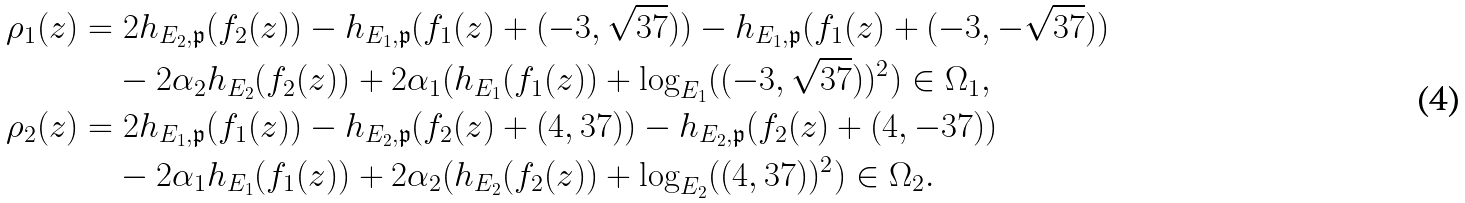Convert formula to latex. <formula><loc_0><loc_0><loc_500><loc_500>\rho _ { 1 } ( z ) & = 2 h _ { E _ { 2 } , \mathfrak { p } } ( f _ { 2 } ( z ) ) - h _ { E _ { 1 } , \mathfrak { p } } ( f _ { 1 } ( z ) + ( - 3 , \sqrt { 3 7 } ) ) - h _ { E _ { 1 } , \mathfrak { p } } ( f _ { 1 } ( z ) + ( - 3 , - \sqrt { 3 7 } ) ) \\ & \quad - 2 \alpha _ { 2 } h _ { E _ { 2 } } ( f _ { 2 } ( z ) ) + 2 \alpha _ { 1 } ( h _ { E _ { 1 } } ( f _ { 1 } ( z ) ) + \log _ { E _ { 1 } } ( ( - 3 , \sqrt { 3 7 } ) ) ^ { 2 } ) \in \Omega _ { 1 } , \\ \rho _ { 2 } ( z ) & = 2 h _ { E _ { 1 } , \mathfrak { p } } ( f _ { 1 } ( z ) ) - h _ { E _ { 2 } , \mathfrak { p } } ( f _ { 2 } ( z ) + ( 4 , 3 7 ) ) - h _ { E _ { 2 } , \mathfrak { p } } ( f _ { 2 } ( z ) + ( 4 , - 3 7 ) ) \\ & \quad - 2 \alpha _ { 1 } h _ { E _ { 1 } } ( f _ { 1 } ( z ) ) + 2 \alpha _ { 2 } ( h _ { E _ { 2 } } ( f _ { 2 } ( z ) ) + \log _ { E _ { 2 } } ( ( 4 , 3 7 ) ) ^ { 2 } ) \in \Omega _ { 2 } .</formula> 